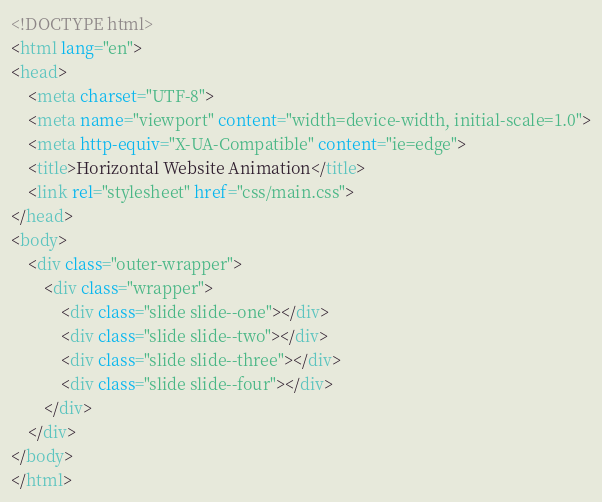<code> <loc_0><loc_0><loc_500><loc_500><_HTML_><!DOCTYPE html>
<html lang="en">
<head>
    <meta charset="UTF-8">
    <meta name="viewport" content="width=device-width, initial-scale=1.0">
    <meta http-equiv="X-UA-Compatible" content="ie=edge">
    <title>Horizontal Website Animation</title>
    <link rel="stylesheet" href="css/main.css">
</head>
<body>
    <div class="outer-wrapper">
        <div class="wrapper">
            <div class="slide slide--one"></div>
            <div class="slide slide--two"></div>
            <div class="slide slide--three"></div>
            <div class="slide slide--four"></div>
        </div>
    </div>
</body>
</html></code> 